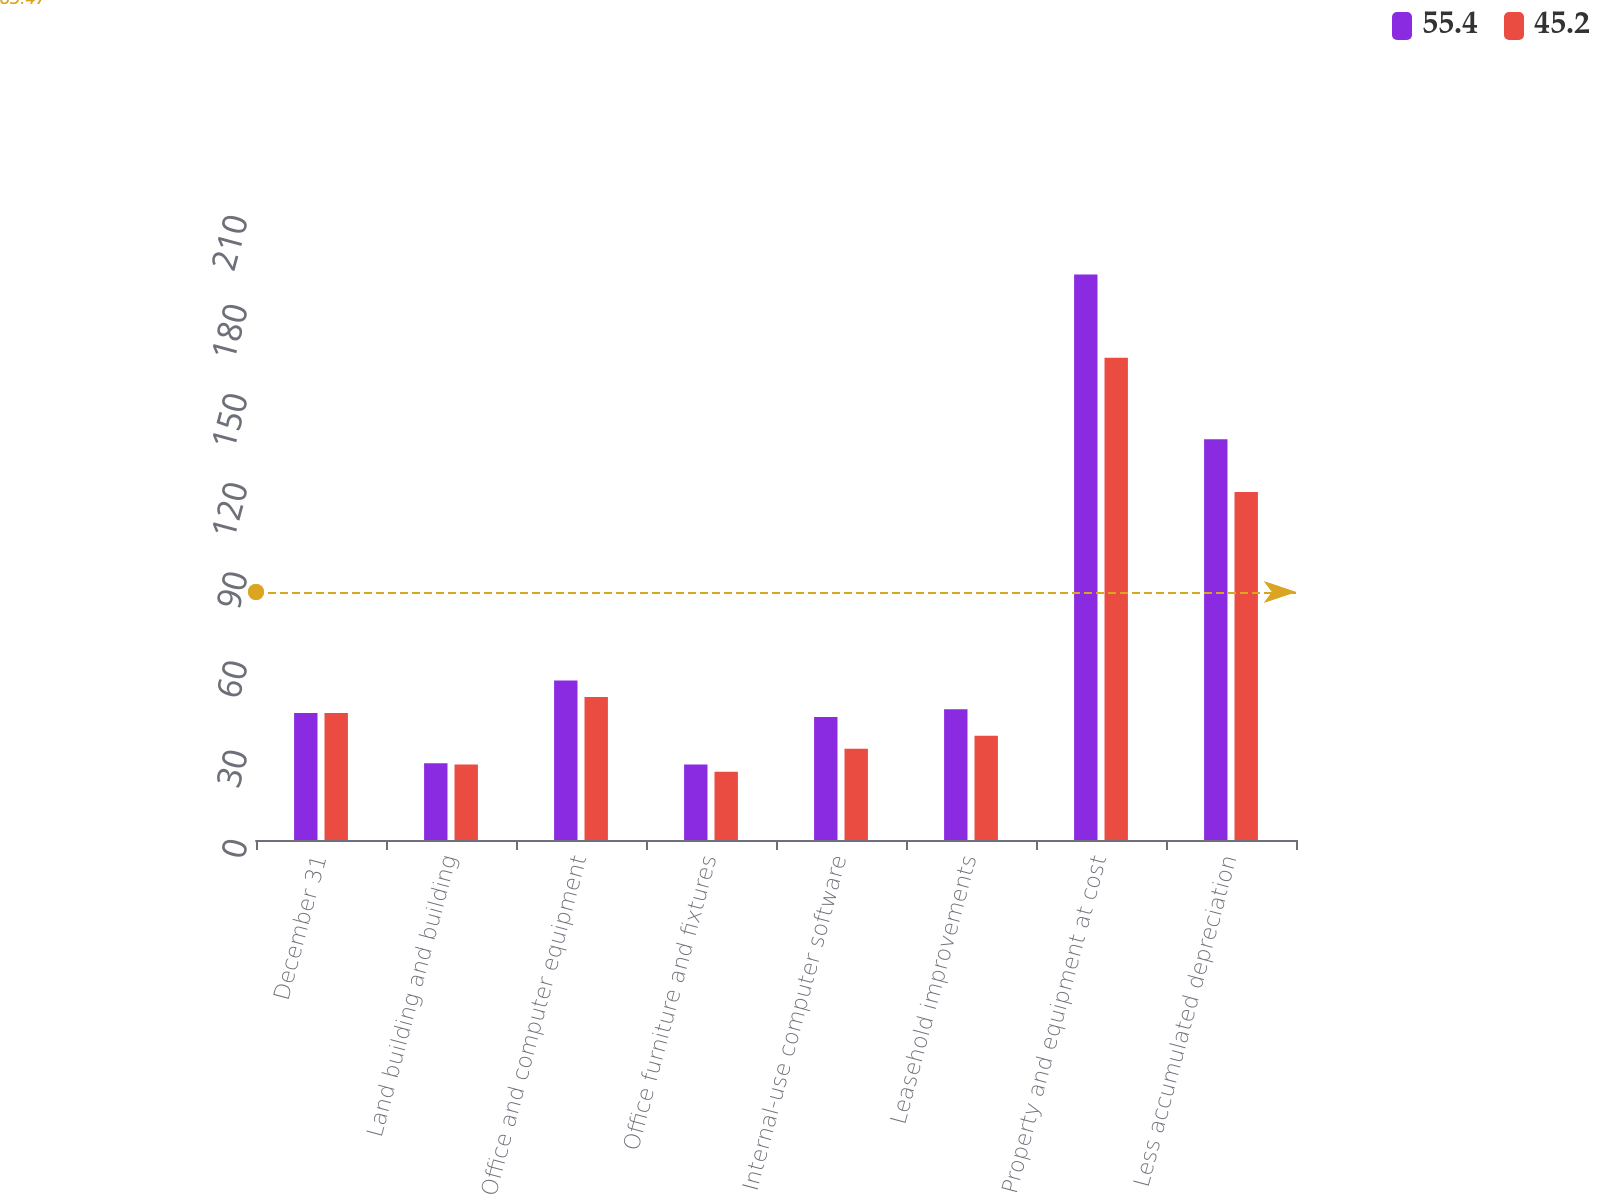Convert chart. <chart><loc_0><loc_0><loc_500><loc_500><stacked_bar_chart><ecel><fcel>December 31<fcel>Land building and building<fcel>Office and computer equipment<fcel>Office furniture and fixtures<fcel>Internal-use computer software<fcel>Leasehold improvements<fcel>Property and equipment at cost<fcel>Less accumulated depreciation<nl><fcel>55.4<fcel>42.7<fcel>25.8<fcel>53.7<fcel>25.4<fcel>41.4<fcel>44<fcel>190.3<fcel>134.9<nl><fcel>45.2<fcel>42.7<fcel>25.4<fcel>48.1<fcel>23<fcel>30.7<fcel>35.1<fcel>162.3<fcel>117.1<nl></chart> 